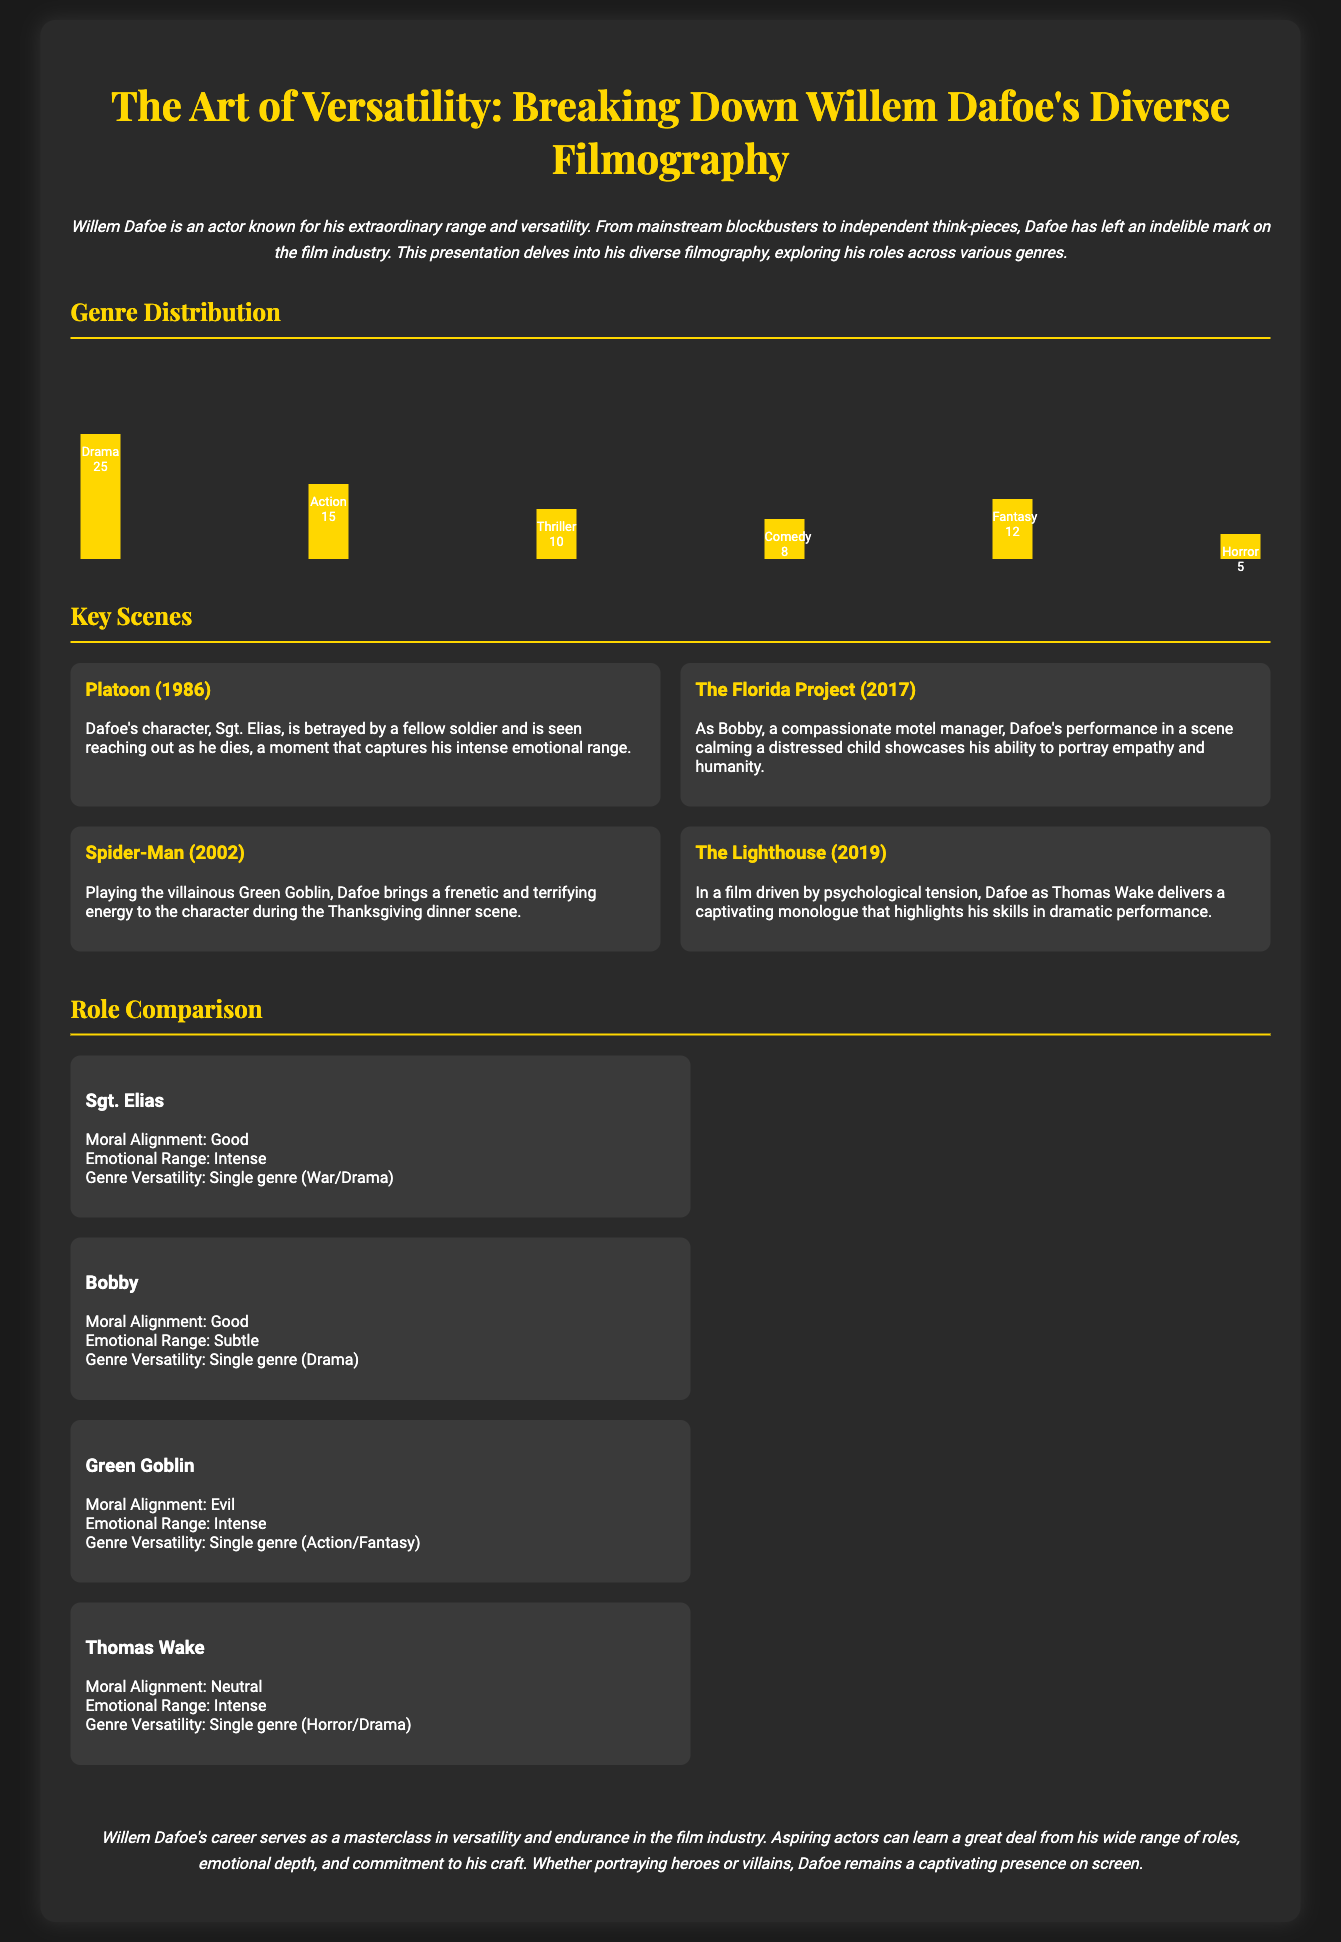What is the total number of Drama roles? The total number of Drama roles listed in the genre distribution is indicated as 25.
Answer: 25 What is the height of the Action genre bar? The height of the Action genre bar visually represents 15, corresponding to the number of roles in that category.
Answer: 15 Which film features Dafoe's character Sgt. Elias? The film where Dafoe plays Sgt. Elias is "Platoon", as stated in the key scenes section.
Answer: Platoon Which character represents moral alignment as "Evil"? The character that has moral alignment classified as "Evil" is the Green Goblin, as detailed in the role comparison section.
Answer: Green Goblin What emotional range is associated with the character Bobby? The emotional range for Bobby is described as "Subtle" in the role comparison section.
Answer: Subtle What is the highest genre representation according to the genre distribution? The highest representation among genres is Drama, with a total of 25 roles.
Answer: Drama Which film showcases Dafoe’s role as a motel manager? The film that features Dafoe as a motel manager is "The Florida Project", highlighted in the key scenes section.
Answer: The Florida Project How many genres are mentioned in the genre distribution? The number of genres mentioned within the distribution is six, corresponding to the listed categories.
Answer: Six What genre does the character Thomas Wake belong to? The character Thomas Wake is associated with the Horror/Drama genres, according to the role comparison.
Answer: Horror/Drama 